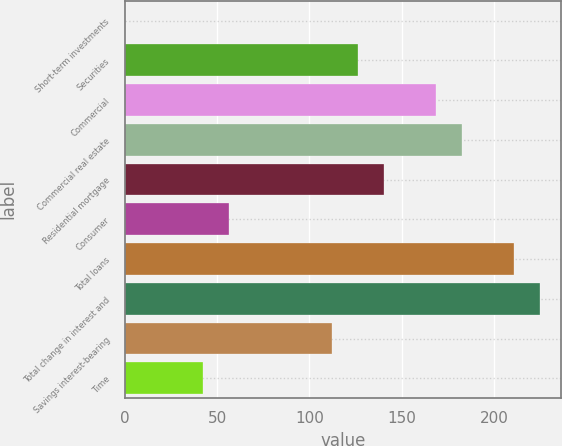Convert chart to OTSL. <chart><loc_0><loc_0><loc_500><loc_500><bar_chart><fcel>Short-term investments<fcel>Securities<fcel>Commercial<fcel>Commercial real estate<fcel>Residential mortgage<fcel>Consumer<fcel>Total loans<fcel>Total change in interest and<fcel>Savings interest-bearing<fcel>Time<nl><fcel>0.1<fcel>126.55<fcel>168.7<fcel>182.75<fcel>140.6<fcel>56.3<fcel>210.85<fcel>224.9<fcel>112.5<fcel>42.25<nl></chart> 